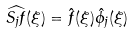Convert formula to latex. <formula><loc_0><loc_0><loc_500><loc_500>\widehat { S _ { j } f } ( \xi ) = \hat { f } ( \xi ) \hat { \phi _ { j } } ( \xi )</formula> 